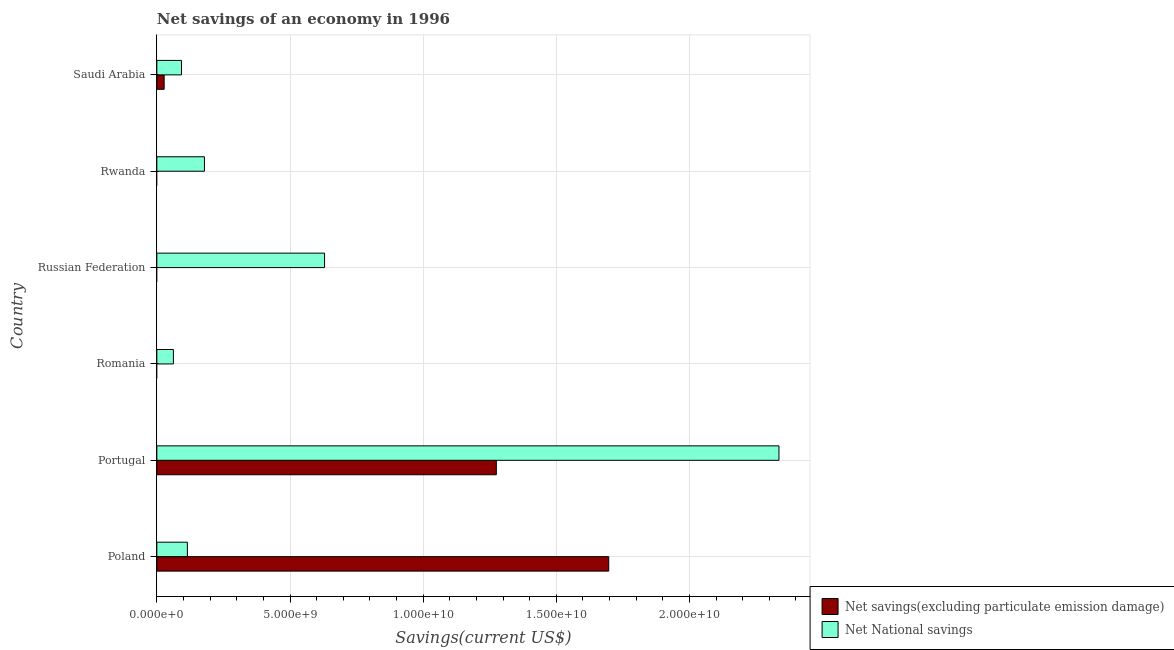Are the number of bars per tick equal to the number of legend labels?
Make the answer very short. No. Are the number of bars on each tick of the Y-axis equal?
Make the answer very short. No. How many bars are there on the 1st tick from the top?
Your answer should be compact. 2. What is the label of the 6th group of bars from the top?
Ensure brevity in your answer.  Poland. What is the net savings(excluding particulate emission damage) in Poland?
Provide a succinct answer. 1.70e+1. Across all countries, what is the maximum net national savings?
Your answer should be very brief. 2.34e+1. Across all countries, what is the minimum net national savings?
Offer a very short reply. 6.21e+08. In which country was the net national savings maximum?
Provide a succinct answer. Portugal. What is the total net national savings in the graph?
Offer a terse response. 3.41e+1. What is the difference between the net national savings in Russian Federation and that in Saudi Arabia?
Offer a terse response. 5.37e+09. What is the difference between the net savings(excluding particulate emission damage) in Russian Federation and the net national savings in Rwanda?
Give a very brief answer. -1.79e+09. What is the average net national savings per country?
Your response must be concise. 5.69e+09. What is the difference between the net national savings and net savings(excluding particulate emission damage) in Poland?
Provide a succinct answer. -1.58e+1. In how many countries, is the net savings(excluding particulate emission damage) greater than 15000000000 US$?
Keep it short and to the point. 1. What is the ratio of the net savings(excluding particulate emission damage) in Portugal to that in Saudi Arabia?
Offer a terse response. 46.45. Is the net national savings in Poland less than that in Portugal?
Offer a terse response. Yes. What is the difference between the highest and the second highest net national savings?
Your answer should be very brief. 1.71e+1. What is the difference between the highest and the lowest net savings(excluding particulate emission damage)?
Your answer should be very brief. 1.70e+1. In how many countries, is the net national savings greater than the average net national savings taken over all countries?
Give a very brief answer. 2. How many bars are there?
Provide a succinct answer. 9. Are all the bars in the graph horizontal?
Your response must be concise. Yes. What is the difference between two consecutive major ticks on the X-axis?
Provide a short and direct response. 5.00e+09. Are the values on the major ticks of X-axis written in scientific E-notation?
Keep it short and to the point. Yes. Does the graph contain grids?
Make the answer very short. Yes. Where does the legend appear in the graph?
Keep it short and to the point. Bottom right. What is the title of the graph?
Give a very brief answer. Net savings of an economy in 1996. Does "Registered firms" appear as one of the legend labels in the graph?
Offer a very short reply. No. What is the label or title of the X-axis?
Provide a short and direct response. Savings(current US$). What is the label or title of the Y-axis?
Make the answer very short. Country. What is the Savings(current US$) in Net savings(excluding particulate emission damage) in Poland?
Your answer should be compact. 1.70e+1. What is the Savings(current US$) in Net National savings in Poland?
Your answer should be very brief. 1.15e+09. What is the Savings(current US$) in Net savings(excluding particulate emission damage) in Portugal?
Your answer should be compact. 1.27e+1. What is the Savings(current US$) in Net National savings in Portugal?
Your response must be concise. 2.34e+1. What is the Savings(current US$) in Net savings(excluding particulate emission damage) in Romania?
Offer a very short reply. 0. What is the Savings(current US$) in Net National savings in Romania?
Your answer should be compact. 6.21e+08. What is the Savings(current US$) in Net National savings in Russian Federation?
Offer a terse response. 6.30e+09. What is the Savings(current US$) of Net National savings in Rwanda?
Offer a very short reply. 1.79e+09. What is the Savings(current US$) of Net savings(excluding particulate emission damage) in Saudi Arabia?
Keep it short and to the point. 2.74e+08. What is the Savings(current US$) of Net National savings in Saudi Arabia?
Your answer should be very brief. 9.25e+08. Across all countries, what is the maximum Savings(current US$) in Net savings(excluding particulate emission damage)?
Your answer should be very brief. 1.70e+1. Across all countries, what is the maximum Savings(current US$) of Net National savings?
Your answer should be compact. 2.34e+1. Across all countries, what is the minimum Savings(current US$) of Net savings(excluding particulate emission damage)?
Your answer should be compact. 0. Across all countries, what is the minimum Savings(current US$) in Net National savings?
Provide a short and direct response. 6.21e+08. What is the total Savings(current US$) of Net savings(excluding particulate emission damage) in the graph?
Offer a terse response. 3.00e+1. What is the total Savings(current US$) in Net National savings in the graph?
Your answer should be compact. 3.41e+1. What is the difference between the Savings(current US$) in Net savings(excluding particulate emission damage) in Poland and that in Portugal?
Your answer should be compact. 4.22e+09. What is the difference between the Savings(current US$) of Net National savings in Poland and that in Portugal?
Ensure brevity in your answer.  -2.22e+1. What is the difference between the Savings(current US$) of Net National savings in Poland and that in Romania?
Keep it short and to the point. 5.25e+08. What is the difference between the Savings(current US$) in Net National savings in Poland and that in Russian Federation?
Your answer should be very brief. -5.15e+09. What is the difference between the Savings(current US$) in Net National savings in Poland and that in Rwanda?
Offer a very short reply. -6.41e+08. What is the difference between the Savings(current US$) in Net savings(excluding particulate emission damage) in Poland and that in Saudi Arabia?
Provide a short and direct response. 1.67e+1. What is the difference between the Savings(current US$) in Net National savings in Poland and that in Saudi Arabia?
Give a very brief answer. 2.21e+08. What is the difference between the Savings(current US$) of Net National savings in Portugal and that in Romania?
Provide a succinct answer. 2.27e+1. What is the difference between the Savings(current US$) of Net National savings in Portugal and that in Russian Federation?
Your response must be concise. 1.71e+1. What is the difference between the Savings(current US$) in Net National savings in Portugal and that in Rwanda?
Offer a terse response. 2.16e+1. What is the difference between the Savings(current US$) in Net savings(excluding particulate emission damage) in Portugal and that in Saudi Arabia?
Your response must be concise. 1.25e+1. What is the difference between the Savings(current US$) of Net National savings in Portugal and that in Saudi Arabia?
Your answer should be very brief. 2.24e+1. What is the difference between the Savings(current US$) in Net National savings in Romania and that in Russian Federation?
Your answer should be compact. -5.68e+09. What is the difference between the Savings(current US$) of Net National savings in Romania and that in Rwanda?
Make the answer very short. -1.17e+09. What is the difference between the Savings(current US$) of Net National savings in Romania and that in Saudi Arabia?
Your response must be concise. -3.04e+08. What is the difference between the Savings(current US$) in Net National savings in Russian Federation and that in Rwanda?
Offer a terse response. 4.51e+09. What is the difference between the Savings(current US$) in Net National savings in Russian Federation and that in Saudi Arabia?
Provide a succinct answer. 5.37e+09. What is the difference between the Savings(current US$) in Net National savings in Rwanda and that in Saudi Arabia?
Your answer should be very brief. 8.63e+08. What is the difference between the Savings(current US$) of Net savings(excluding particulate emission damage) in Poland and the Savings(current US$) of Net National savings in Portugal?
Your response must be concise. -6.39e+09. What is the difference between the Savings(current US$) of Net savings(excluding particulate emission damage) in Poland and the Savings(current US$) of Net National savings in Romania?
Provide a succinct answer. 1.63e+1. What is the difference between the Savings(current US$) in Net savings(excluding particulate emission damage) in Poland and the Savings(current US$) in Net National savings in Russian Federation?
Provide a short and direct response. 1.07e+1. What is the difference between the Savings(current US$) of Net savings(excluding particulate emission damage) in Poland and the Savings(current US$) of Net National savings in Rwanda?
Make the answer very short. 1.52e+1. What is the difference between the Savings(current US$) of Net savings(excluding particulate emission damage) in Poland and the Savings(current US$) of Net National savings in Saudi Arabia?
Offer a very short reply. 1.60e+1. What is the difference between the Savings(current US$) in Net savings(excluding particulate emission damage) in Portugal and the Savings(current US$) in Net National savings in Romania?
Your answer should be very brief. 1.21e+1. What is the difference between the Savings(current US$) in Net savings(excluding particulate emission damage) in Portugal and the Savings(current US$) in Net National savings in Russian Federation?
Offer a terse response. 6.45e+09. What is the difference between the Savings(current US$) of Net savings(excluding particulate emission damage) in Portugal and the Savings(current US$) of Net National savings in Rwanda?
Your response must be concise. 1.10e+1. What is the difference between the Savings(current US$) of Net savings(excluding particulate emission damage) in Portugal and the Savings(current US$) of Net National savings in Saudi Arabia?
Provide a short and direct response. 1.18e+1. What is the average Savings(current US$) of Net savings(excluding particulate emission damage) per country?
Make the answer very short. 5.00e+09. What is the average Savings(current US$) of Net National savings per country?
Give a very brief answer. 5.69e+09. What is the difference between the Savings(current US$) of Net savings(excluding particulate emission damage) and Savings(current US$) of Net National savings in Poland?
Ensure brevity in your answer.  1.58e+1. What is the difference between the Savings(current US$) in Net savings(excluding particulate emission damage) and Savings(current US$) in Net National savings in Portugal?
Keep it short and to the point. -1.06e+1. What is the difference between the Savings(current US$) of Net savings(excluding particulate emission damage) and Savings(current US$) of Net National savings in Saudi Arabia?
Give a very brief answer. -6.51e+08. What is the ratio of the Savings(current US$) in Net savings(excluding particulate emission damage) in Poland to that in Portugal?
Your response must be concise. 1.33. What is the ratio of the Savings(current US$) in Net National savings in Poland to that in Portugal?
Offer a very short reply. 0.05. What is the ratio of the Savings(current US$) in Net National savings in Poland to that in Romania?
Give a very brief answer. 1.85. What is the ratio of the Savings(current US$) in Net National savings in Poland to that in Russian Federation?
Provide a short and direct response. 0.18. What is the ratio of the Savings(current US$) of Net National savings in Poland to that in Rwanda?
Give a very brief answer. 0.64. What is the ratio of the Savings(current US$) of Net savings(excluding particulate emission damage) in Poland to that in Saudi Arabia?
Offer a terse response. 61.84. What is the ratio of the Savings(current US$) in Net National savings in Poland to that in Saudi Arabia?
Your answer should be very brief. 1.24. What is the ratio of the Savings(current US$) in Net National savings in Portugal to that in Romania?
Your answer should be very brief. 37.61. What is the ratio of the Savings(current US$) of Net National savings in Portugal to that in Russian Federation?
Offer a terse response. 3.71. What is the ratio of the Savings(current US$) of Net National savings in Portugal to that in Rwanda?
Offer a terse response. 13.07. What is the ratio of the Savings(current US$) of Net savings(excluding particulate emission damage) in Portugal to that in Saudi Arabia?
Your response must be concise. 46.45. What is the ratio of the Savings(current US$) of Net National savings in Portugal to that in Saudi Arabia?
Provide a succinct answer. 25.26. What is the ratio of the Savings(current US$) in Net National savings in Romania to that in Russian Federation?
Give a very brief answer. 0.1. What is the ratio of the Savings(current US$) of Net National savings in Romania to that in Rwanda?
Keep it short and to the point. 0.35. What is the ratio of the Savings(current US$) in Net National savings in Romania to that in Saudi Arabia?
Offer a terse response. 0.67. What is the ratio of the Savings(current US$) of Net National savings in Russian Federation to that in Rwanda?
Provide a succinct answer. 3.52. What is the ratio of the Savings(current US$) of Net National savings in Russian Federation to that in Saudi Arabia?
Provide a succinct answer. 6.81. What is the ratio of the Savings(current US$) in Net National savings in Rwanda to that in Saudi Arabia?
Your answer should be compact. 1.93. What is the difference between the highest and the second highest Savings(current US$) in Net savings(excluding particulate emission damage)?
Keep it short and to the point. 4.22e+09. What is the difference between the highest and the second highest Savings(current US$) in Net National savings?
Provide a succinct answer. 1.71e+1. What is the difference between the highest and the lowest Savings(current US$) in Net savings(excluding particulate emission damage)?
Provide a short and direct response. 1.70e+1. What is the difference between the highest and the lowest Savings(current US$) of Net National savings?
Offer a very short reply. 2.27e+1. 